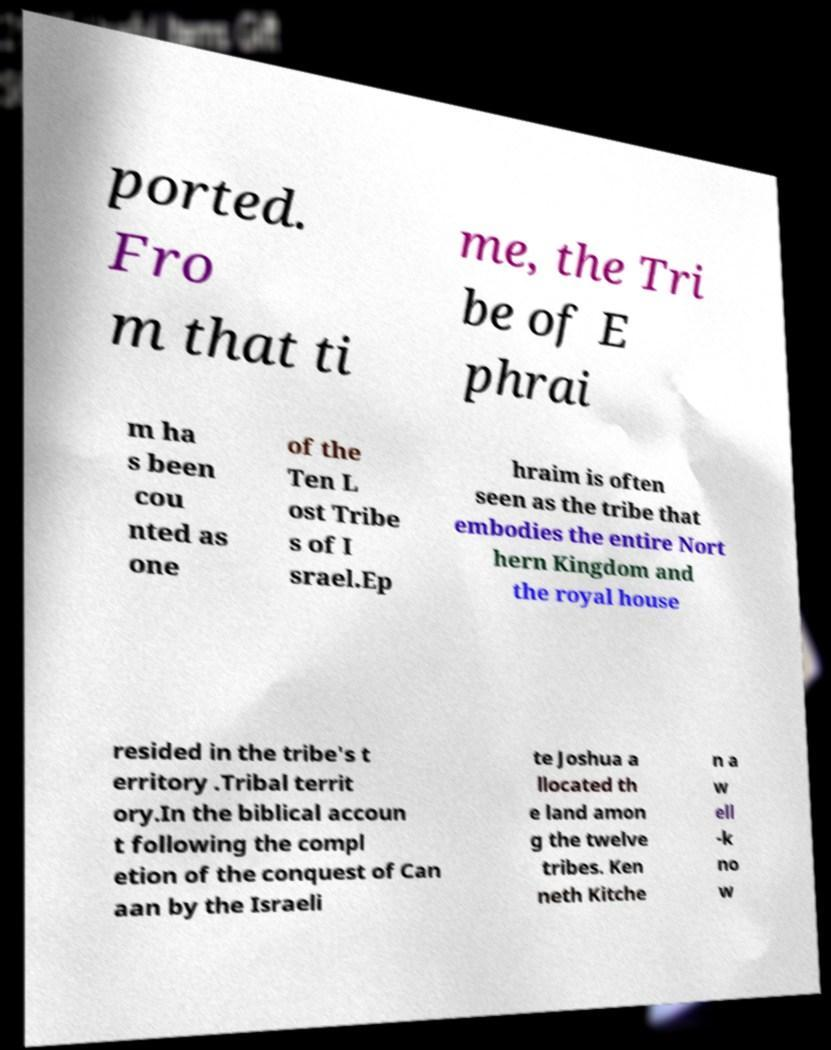Please identify and transcribe the text found in this image. ported. Fro m that ti me, the Tri be of E phrai m ha s been cou nted as one of the Ten L ost Tribe s of I srael.Ep hraim is often seen as the tribe that embodies the entire Nort hern Kingdom and the royal house resided in the tribe's t erritory .Tribal territ ory.In the biblical accoun t following the compl etion of the conquest of Can aan by the Israeli te Joshua a llocated th e land amon g the twelve tribes. Ken neth Kitche n a w ell -k no w 